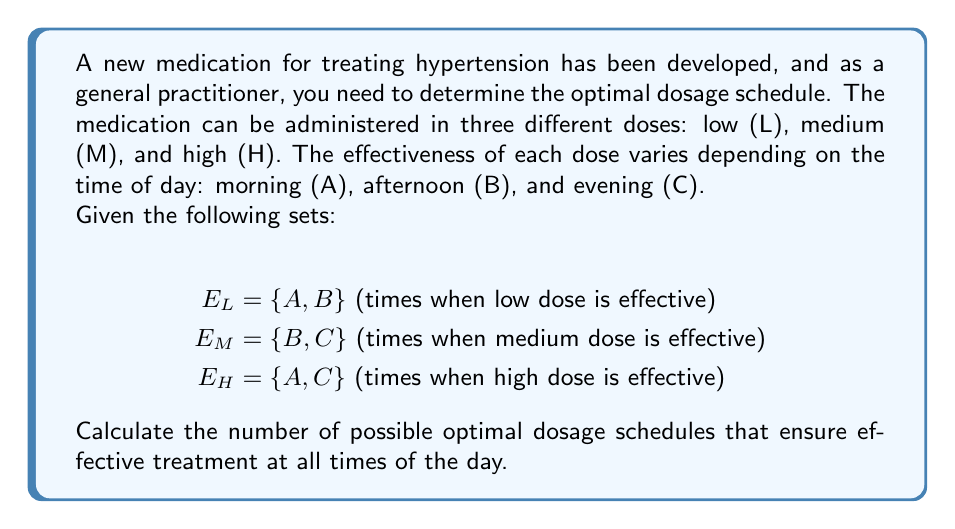Could you help me with this problem? To solve this problem, we need to use set theory concepts to determine the number of valid combinations that cover all time periods (A, B, and C) with effective doses.

Step 1: Identify the universe set
The universe set U contains all time periods: U = {A, B, C}

Step 2: Analyze the coverage of each dose
- Low dose (L) covers A and B
- Medium dose (M) covers B and C
- High dose (H) covers A and C

Step 3: Determine the minimum number of doses needed
We need at least two doses to cover all time periods, as no single dose covers all three periods.

Step 4: List all possible combinations of two doses
(L, M), (L, H), (M, H)

Step 5: Check each combination for complete coverage
- (L, M): $E_L \cup E_M = \{A, B\} \cup \{B, C\} = \{A, B, C\}$ (covers all periods)
- (L, H): $E_L \cup E_H = \{A, B\} \cup \{A, C\} = \{A, B, C\}$ (covers all periods)
- (M, H): $E_M \cup E_H = \{B, C\} \cup \{A, C\} = \{A, B, C\}$ (covers all periods)

Step 6: Count the number of valid combinations
All three combinations of two doses provide complete coverage.

Step 7: Consider combinations of three doses
The combination (L, M, H) also provides complete coverage: $E_L \cup E_M \cup E_H = \{A, B, C\}$

Step 8: Calculate the total number of optimal dosage schedules
Total number of optimal schedules = 3 (two-dose combinations) + 1 (three-dose combination) = 4
Answer: The number of possible optimal dosage schedules that ensure effective treatment at all times of the day is 4. 